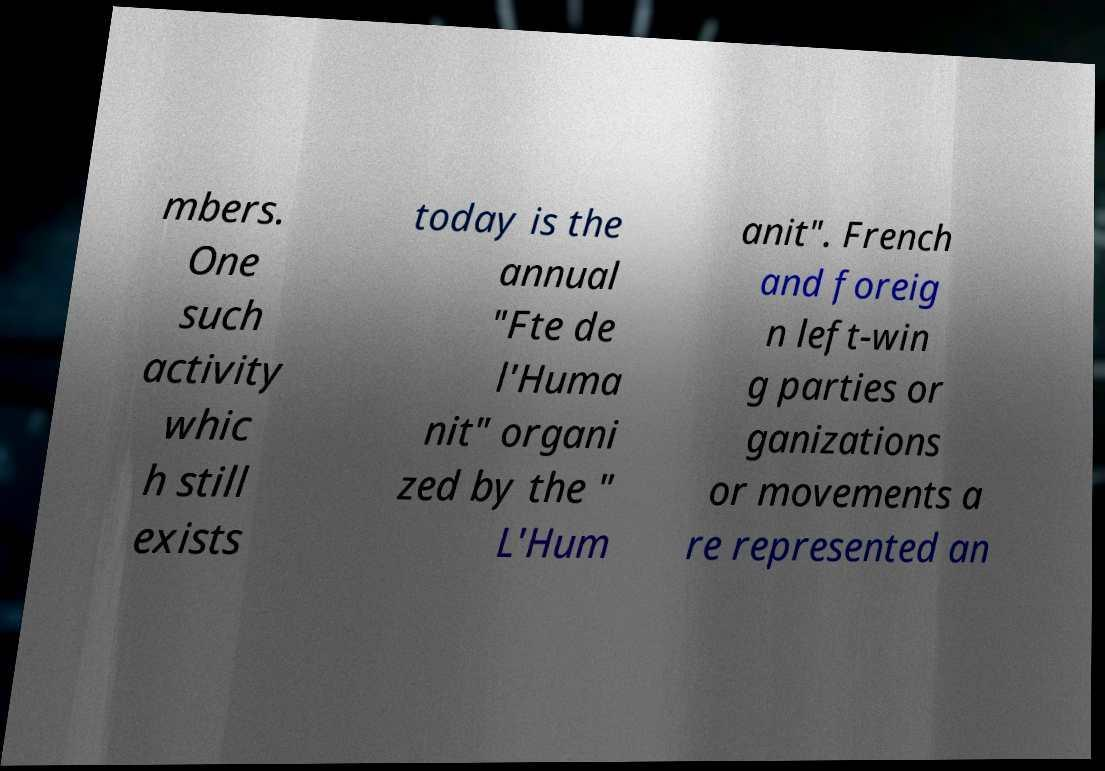Could you extract and type out the text from this image? mbers. One such activity whic h still exists today is the annual "Fte de l'Huma nit" organi zed by the " L'Hum anit". French and foreig n left-win g parties or ganizations or movements a re represented an 